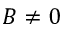<formula> <loc_0><loc_0><loc_500><loc_500>B \neq 0</formula> 